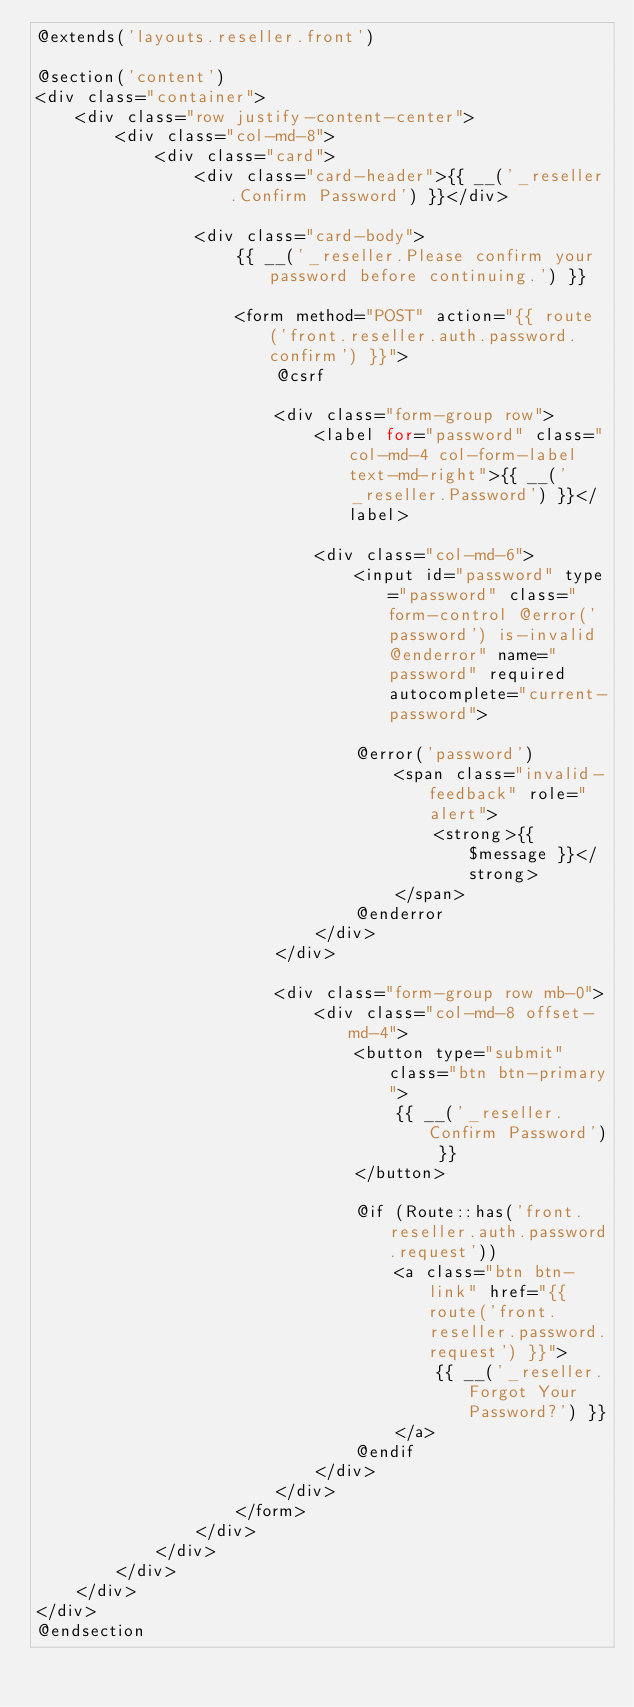<code> <loc_0><loc_0><loc_500><loc_500><_PHP_>@extends('layouts.reseller.front')

@section('content')
<div class="container">
    <div class="row justify-content-center">
        <div class="col-md-8">
            <div class="card">
                <div class="card-header">{{ __('_reseller.Confirm Password') }}</div>

                <div class="card-body">
                    {{ __('_reseller.Please confirm your password before continuing.') }}

                    <form method="POST" action="{{ route('front.reseller.auth.password.confirm') }}">
                        @csrf

                        <div class="form-group row">
                            <label for="password" class="col-md-4 col-form-label text-md-right">{{ __('_reseller.Password') }}</label>

                            <div class="col-md-6">
                                <input id="password" type="password" class="form-control @error('password') is-invalid @enderror" name="password" required autocomplete="current-password">

                                @error('password')
                                    <span class="invalid-feedback" role="alert">
                                        <strong>{{ $message }}</strong>
                                    </span>
                                @enderror
                            </div>
                        </div>

                        <div class="form-group row mb-0">
                            <div class="col-md-8 offset-md-4">
                                <button type="submit" class="btn btn-primary">
                                    {{ __('_reseller.Confirm Password') }}
                                </button>

                                @if (Route::has('front.reseller.auth.password.request'))
                                    <a class="btn btn-link" href="{{ route('front.reseller.password.request') }}">
                                        {{ __('_reseller.Forgot Your Password?') }}
                                    </a>
                                @endif
                            </div>
                        </div>
                    </form>
                </div>
            </div>
        </div>
    </div>
</div>
@endsection
</code> 